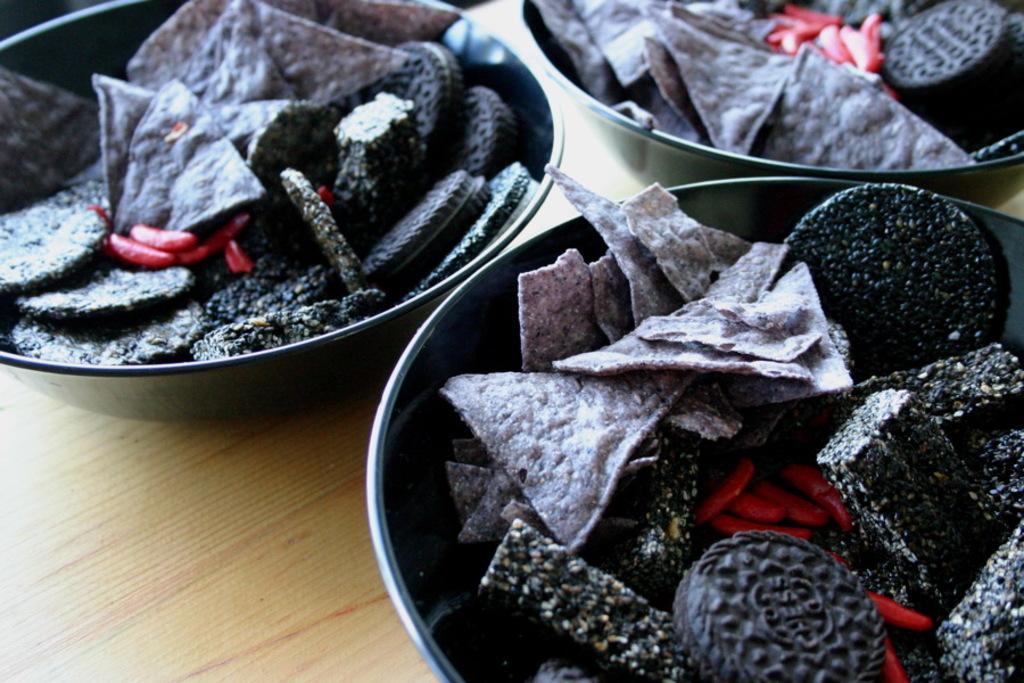Can you describe this image briefly? In this image there are foods in the plates which is on the wooden table. 